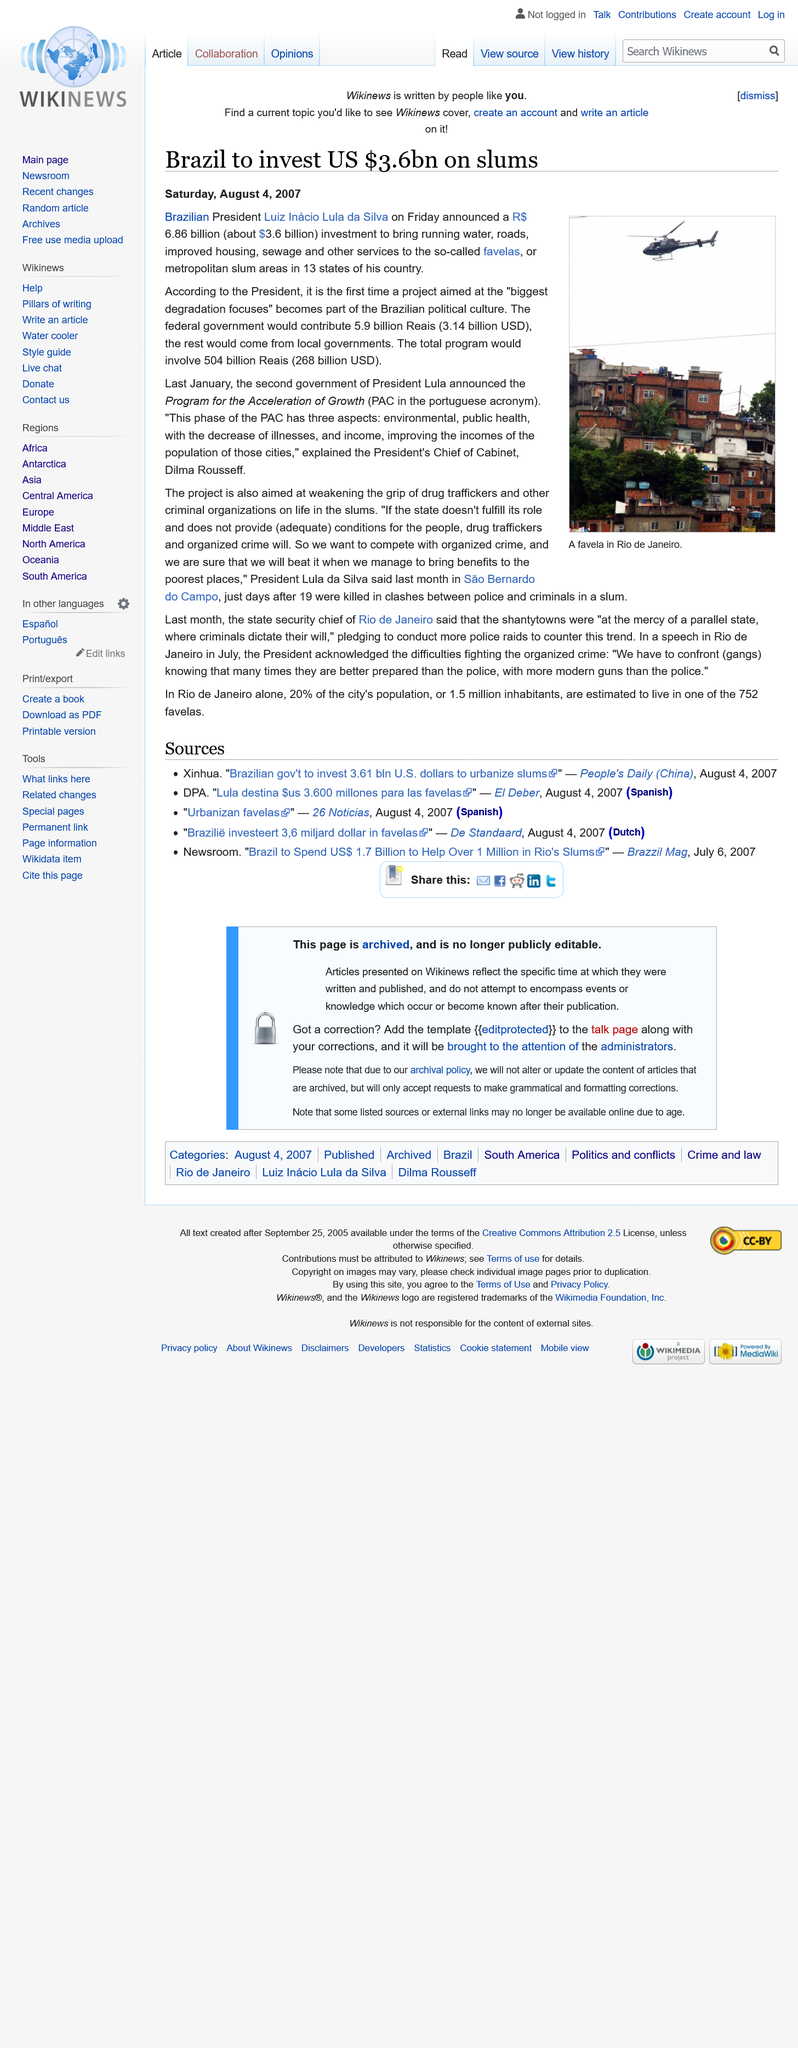Give some essential details in this illustration. At the time this article was written, Luiz Inacio Lula da Silva was the president of Brazil. Metropolitan slums, also known as favelas, are well-known within the global community as areas of extreme poverty and social inequality. These impoverished neighborhoods, often located on the outskirts of major cities, are characterized by overcrowding, insufficient housing, and limited access to basic services, such as education and healthcare. Despite efforts to improve living conditions in favelas, they continue to be plagued by crime, violence, and social exclusion. The currency of Brazil is the Brazilian real. 